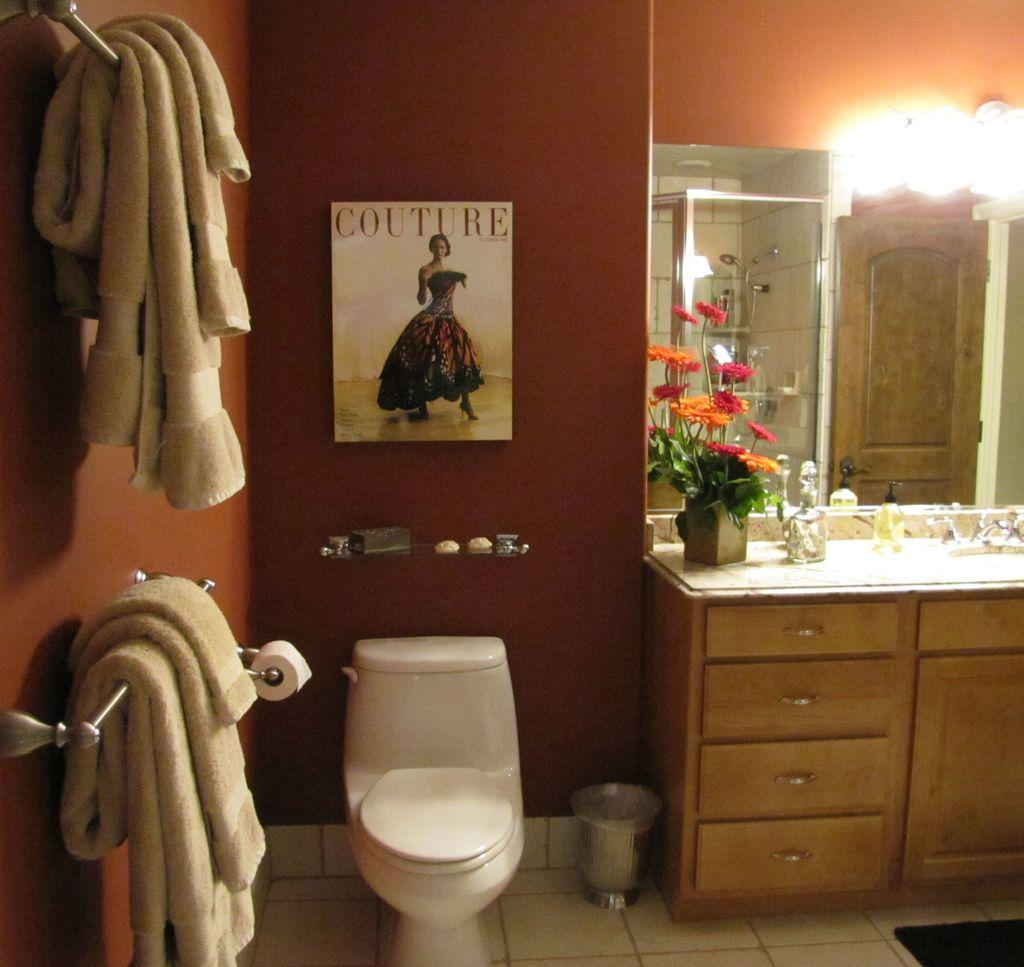What is hanging on the wall in the image? There is a poster on the wall in the image. What can be seen in the bathroom in the image? A toilet seat, a flush tank, a dustbin, a tissue paper roll, a tap, cupboards, a mirror, and lights are visible in the bathroom in the image. How are the towels arranged in the image? The towels are on hangers in the image. What type of truck is parked outside the bathroom in the image? There is no truck visible in the image; it is focused on the bathroom interior. How many people are in the group that is using the bathroom in the image? There is no group of people present in the image; it only shows the bathroom fixtures and accessories. 